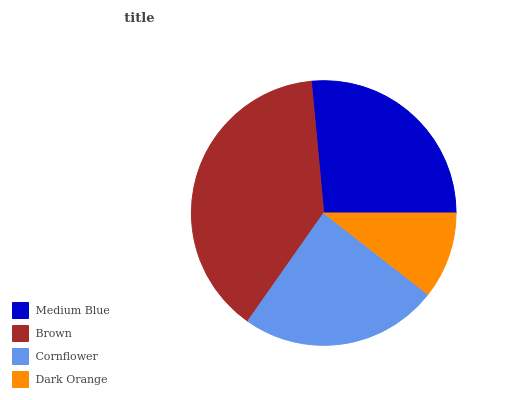Is Dark Orange the minimum?
Answer yes or no. Yes. Is Brown the maximum?
Answer yes or no. Yes. Is Cornflower the minimum?
Answer yes or no. No. Is Cornflower the maximum?
Answer yes or no. No. Is Brown greater than Cornflower?
Answer yes or no. Yes. Is Cornflower less than Brown?
Answer yes or no. Yes. Is Cornflower greater than Brown?
Answer yes or no. No. Is Brown less than Cornflower?
Answer yes or no. No. Is Medium Blue the high median?
Answer yes or no. Yes. Is Cornflower the low median?
Answer yes or no. Yes. Is Dark Orange the high median?
Answer yes or no. No. Is Dark Orange the low median?
Answer yes or no. No. 